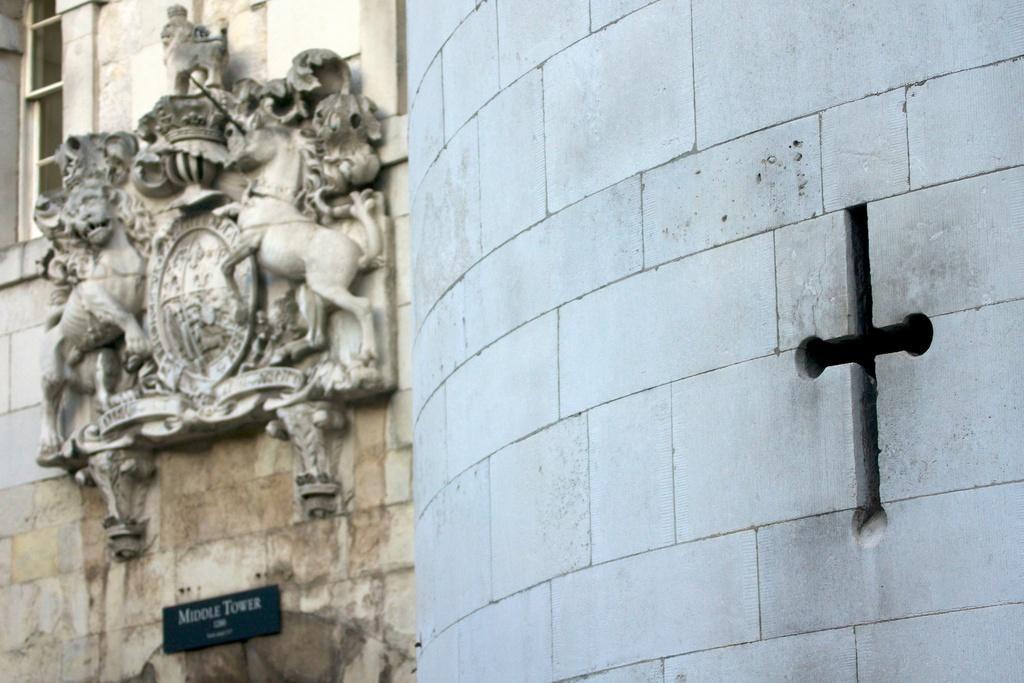Describe this image in one or two sentences. In this image on there is a wall and on the left side of the image there are sculptures, and there is a window board. On the board there is text, and on the right side of the image there is cross sign. 